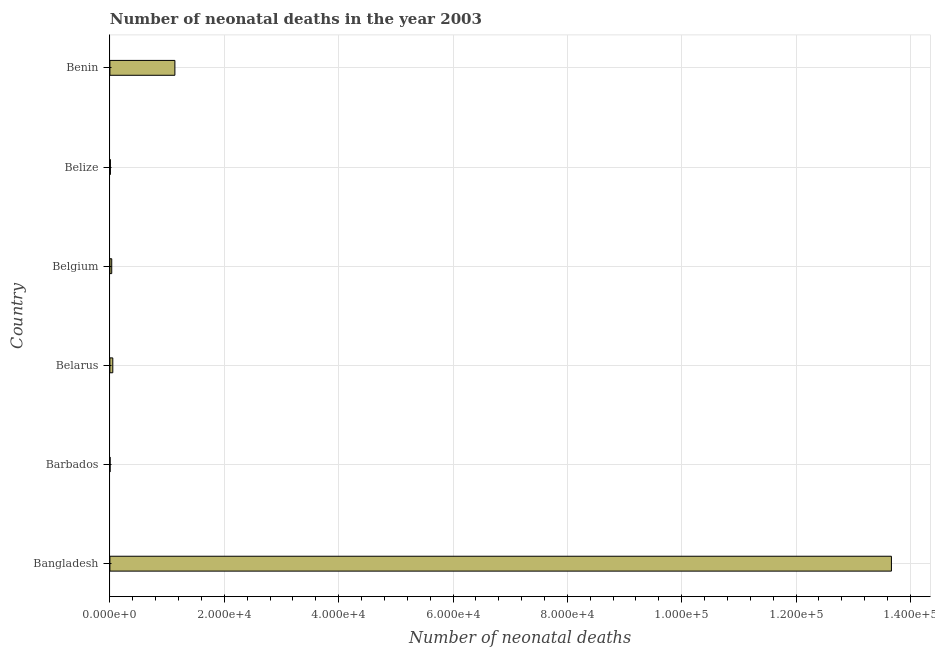Does the graph contain any zero values?
Keep it short and to the point. No. Does the graph contain grids?
Offer a very short reply. Yes. What is the title of the graph?
Keep it short and to the point. Number of neonatal deaths in the year 2003. What is the label or title of the X-axis?
Offer a terse response. Number of neonatal deaths. What is the number of neonatal deaths in Bangladesh?
Your answer should be compact. 1.37e+05. Across all countries, what is the maximum number of neonatal deaths?
Keep it short and to the point. 1.37e+05. Across all countries, what is the minimum number of neonatal deaths?
Make the answer very short. 34. In which country was the number of neonatal deaths minimum?
Provide a short and direct response. Barbados. What is the sum of the number of neonatal deaths?
Keep it short and to the point. 1.49e+05. What is the difference between the number of neonatal deaths in Belize and Benin?
Your answer should be compact. -1.13e+04. What is the average number of neonatal deaths per country?
Your response must be concise. 2.48e+04. What is the median number of neonatal deaths?
Make the answer very short. 414.5. What is the ratio of the number of neonatal deaths in Belgium to that in Belize?
Your response must be concise. 3.69. What is the difference between the highest and the second highest number of neonatal deaths?
Your answer should be compact. 1.25e+05. What is the difference between the highest and the lowest number of neonatal deaths?
Your answer should be compact. 1.37e+05. How many countries are there in the graph?
Offer a terse response. 6. What is the Number of neonatal deaths of Bangladesh?
Ensure brevity in your answer.  1.37e+05. What is the Number of neonatal deaths in Belarus?
Your answer should be compact. 508. What is the Number of neonatal deaths of Belgium?
Your response must be concise. 321. What is the Number of neonatal deaths in Belize?
Your answer should be very brief. 87. What is the Number of neonatal deaths in Benin?
Your answer should be very brief. 1.14e+04. What is the difference between the Number of neonatal deaths in Bangladesh and Barbados?
Your answer should be compact. 1.37e+05. What is the difference between the Number of neonatal deaths in Bangladesh and Belarus?
Provide a short and direct response. 1.36e+05. What is the difference between the Number of neonatal deaths in Bangladesh and Belgium?
Keep it short and to the point. 1.36e+05. What is the difference between the Number of neonatal deaths in Bangladesh and Belize?
Offer a terse response. 1.37e+05. What is the difference between the Number of neonatal deaths in Bangladesh and Benin?
Offer a very short reply. 1.25e+05. What is the difference between the Number of neonatal deaths in Barbados and Belarus?
Your answer should be very brief. -474. What is the difference between the Number of neonatal deaths in Barbados and Belgium?
Provide a short and direct response. -287. What is the difference between the Number of neonatal deaths in Barbados and Belize?
Ensure brevity in your answer.  -53. What is the difference between the Number of neonatal deaths in Barbados and Benin?
Offer a terse response. -1.13e+04. What is the difference between the Number of neonatal deaths in Belarus and Belgium?
Your answer should be very brief. 187. What is the difference between the Number of neonatal deaths in Belarus and Belize?
Your answer should be very brief. 421. What is the difference between the Number of neonatal deaths in Belarus and Benin?
Your response must be concise. -1.09e+04. What is the difference between the Number of neonatal deaths in Belgium and Belize?
Ensure brevity in your answer.  234. What is the difference between the Number of neonatal deaths in Belgium and Benin?
Offer a very short reply. -1.10e+04. What is the difference between the Number of neonatal deaths in Belize and Benin?
Provide a succinct answer. -1.13e+04. What is the ratio of the Number of neonatal deaths in Bangladesh to that in Barbados?
Your answer should be compact. 4019.65. What is the ratio of the Number of neonatal deaths in Bangladesh to that in Belarus?
Your answer should be compact. 269.03. What is the ratio of the Number of neonatal deaths in Bangladesh to that in Belgium?
Provide a succinct answer. 425.76. What is the ratio of the Number of neonatal deaths in Bangladesh to that in Belize?
Offer a terse response. 1570.9. What is the ratio of the Number of neonatal deaths in Bangladesh to that in Benin?
Give a very brief answer. 12.02. What is the ratio of the Number of neonatal deaths in Barbados to that in Belarus?
Offer a very short reply. 0.07. What is the ratio of the Number of neonatal deaths in Barbados to that in Belgium?
Keep it short and to the point. 0.11. What is the ratio of the Number of neonatal deaths in Barbados to that in Belize?
Offer a terse response. 0.39. What is the ratio of the Number of neonatal deaths in Barbados to that in Benin?
Offer a terse response. 0. What is the ratio of the Number of neonatal deaths in Belarus to that in Belgium?
Make the answer very short. 1.58. What is the ratio of the Number of neonatal deaths in Belarus to that in Belize?
Make the answer very short. 5.84. What is the ratio of the Number of neonatal deaths in Belarus to that in Benin?
Your answer should be compact. 0.04. What is the ratio of the Number of neonatal deaths in Belgium to that in Belize?
Give a very brief answer. 3.69. What is the ratio of the Number of neonatal deaths in Belgium to that in Benin?
Offer a terse response. 0.03. What is the ratio of the Number of neonatal deaths in Belize to that in Benin?
Provide a short and direct response. 0.01. 